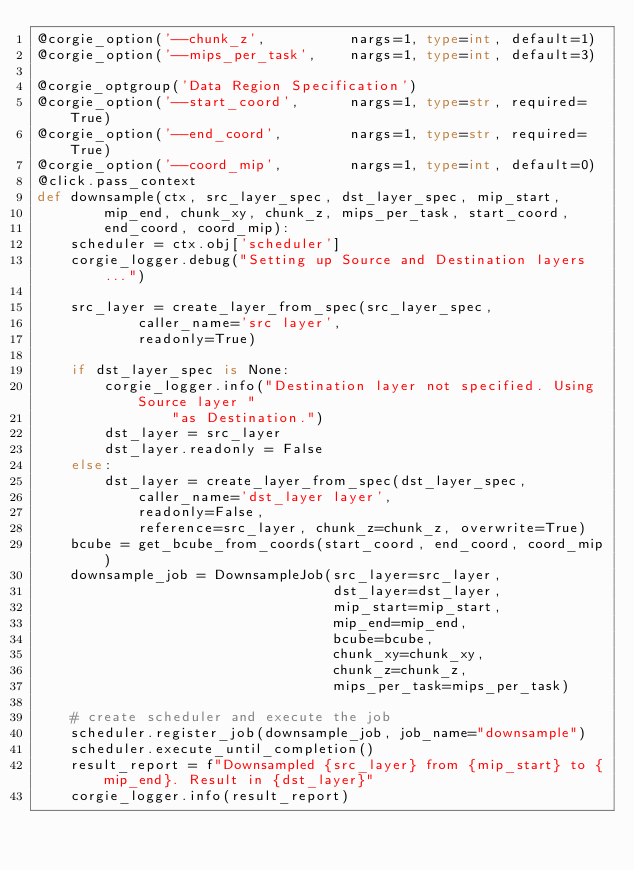<code> <loc_0><loc_0><loc_500><loc_500><_Python_>@corgie_option('--chunk_z',          nargs=1, type=int, default=1)
@corgie_option('--mips_per_task',    nargs=1, type=int, default=3)

@corgie_optgroup('Data Region Specification')
@corgie_option('--start_coord',      nargs=1, type=str, required=True)
@corgie_option('--end_coord',        nargs=1, type=str, required=True)
@corgie_option('--coord_mip',        nargs=1, type=int, default=0)
@click.pass_context
def downsample(ctx, src_layer_spec, dst_layer_spec, mip_start,
        mip_end, chunk_xy, chunk_z, mips_per_task, start_coord,
        end_coord, coord_mip):
    scheduler = ctx.obj['scheduler']
    corgie_logger.debug("Setting up Source and Destination layers...")

    src_layer = create_layer_from_spec(src_layer_spec,
            caller_name='src layer',
            readonly=True)

    if dst_layer_spec is None:
        corgie_logger.info("Destination layer not specified. Using Source layer "
                "as Destination.")
        dst_layer = src_layer
        dst_layer.readonly = False
    else:
        dst_layer = create_layer_from_spec(dst_layer_spec,
            caller_name='dst_layer layer',
            readonly=False,
            reference=src_layer, chunk_z=chunk_z, overwrite=True)
    bcube = get_bcube_from_coords(start_coord, end_coord, coord_mip)
    downsample_job = DownsampleJob(src_layer=src_layer,
                                   dst_layer=dst_layer,
                                   mip_start=mip_start,
                                   mip_end=mip_end,
                                   bcube=bcube,
                                   chunk_xy=chunk_xy,
                                   chunk_z=chunk_z,
                                   mips_per_task=mips_per_task)

    # create scheduler and execute the job
    scheduler.register_job(downsample_job, job_name="downsample")
    scheduler.execute_until_completion()
    result_report = f"Downsampled {src_layer} from {mip_start} to {mip_end}. Result in {dst_layer}"
    corgie_logger.info(result_report)
</code> 